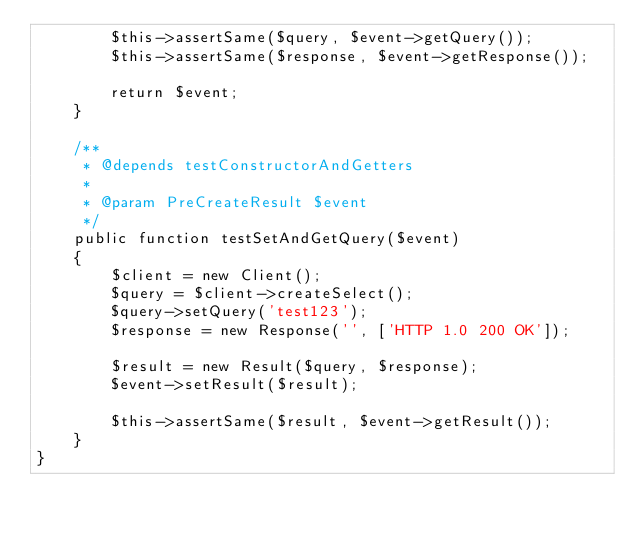<code> <loc_0><loc_0><loc_500><loc_500><_PHP_>        $this->assertSame($query, $event->getQuery());
        $this->assertSame($response, $event->getResponse());

        return $event;
    }

    /**
     * @depends testConstructorAndGetters
     *
     * @param PreCreateResult $event
     */
    public function testSetAndGetQuery($event)
    {
        $client = new Client();
        $query = $client->createSelect();
        $query->setQuery('test123');
        $response = new Response('', ['HTTP 1.0 200 OK']);

        $result = new Result($query, $response);
        $event->setResult($result);

        $this->assertSame($result, $event->getResult());
    }
}
</code> 